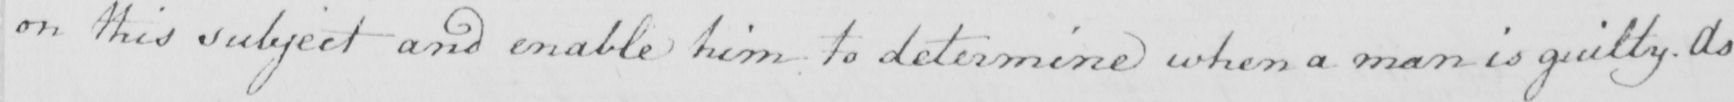Please transcribe the handwritten text in this image. on this subject and enable him to determine when a man is guilty . As 